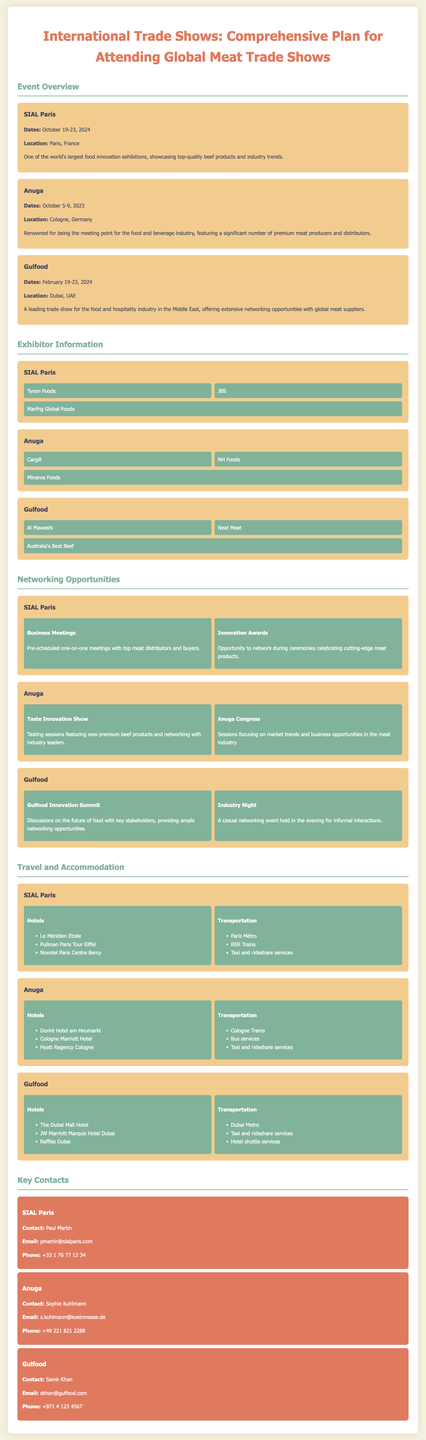What are the dates for SIAL Paris? The dates for SIAL Paris are October 19-23, 2024.
Answer: October 19-23, 2024 Where is Anuga held? Anuga is held in Cologne, Germany.
Answer: Cologne, Germany Which company is an exhibitor at Gulfood? Al Mawashi is listed as an exhibitor at Gulfood.
Answer: Al Mawashi What type of networking opportunity is offered at SIAL Paris? Business Meetings are a networking opportunity at SIAL Paris.
Answer: Business Meetings How many hotels are listed for Anuga? There are three hotels listed for Anuga.
Answer: Three What is the contact email for Samir Khan? The contact email for Samir Khan is skhan@gulfood.com.
Answer: skhan@gulfood.com Which trade show occurs first in 2023? Anuga occurs first in 2023.
Answer: Anuga What is a scheduled activity during Gulfood? The Gulfood Innovation Summit is a scheduled activity during Gulfood.
Answer: Gulfood Innovation Summit Name one of the transportation options for SIAL Paris. Paris Métro is one of the transportation options for SIAL Paris.
Answer: Paris Métro 